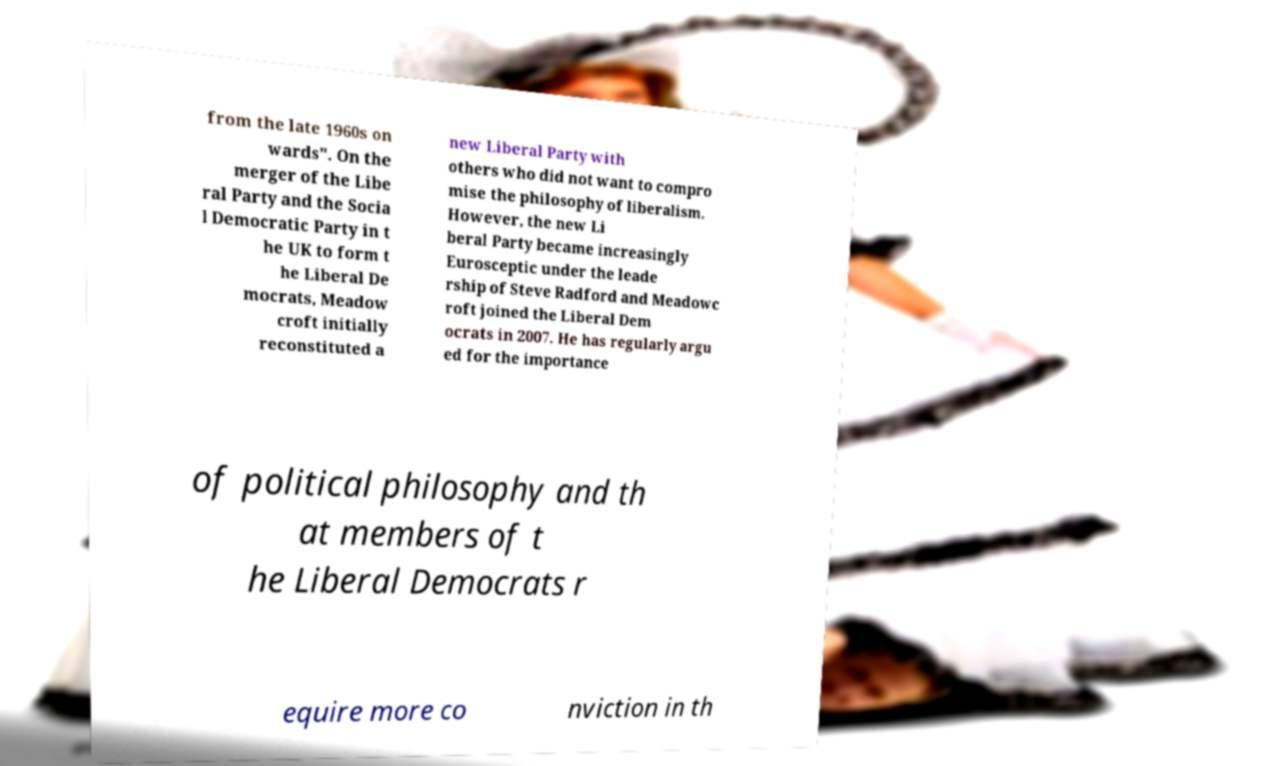Can you accurately transcribe the text from the provided image for me? from the late 1960s on wards". On the merger of the Libe ral Party and the Socia l Democratic Party in t he UK to form t he Liberal De mocrats, Meadow croft initially reconstituted a new Liberal Party with others who did not want to compro mise the philosophy of liberalism. However, the new Li beral Party became increasingly Eurosceptic under the leade rship of Steve Radford and Meadowc roft joined the Liberal Dem ocrats in 2007. He has regularly argu ed for the importance of political philosophy and th at members of t he Liberal Democrats r equire more co nviction in th 